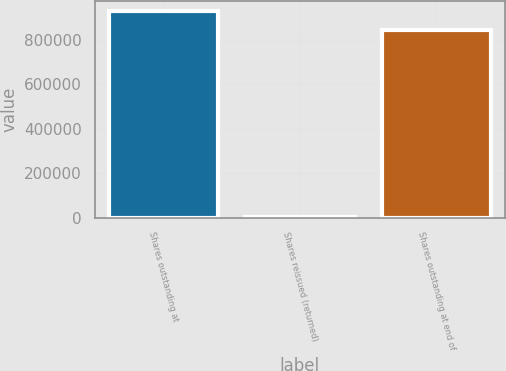Convert chart. <chart><loc_0><loc_0><loc_500><loc_500><bar_chart><fcel>Shares outstanding at<fcel>Shares reissued (returned)<fcel>Shares outstanding at end of<nl><fcel>928552<fcel>1482<fcel>843608<nl></chart> 